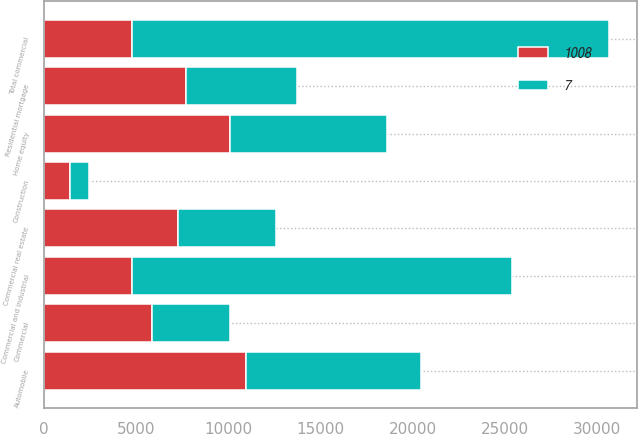Convert chart. <chart><loc_0><loc_0><loc_500><loc_500><stacked_bar_chart><ecel><fcel>Commercial and industrial<fcel>Construction<fcel>Commercial<fcel>Commercial real estate<fcel>Total commercial<fcel>Automobile<fcel>Home equity<fcel>Residential mortgage<nl><fcel>1008<fcel>4752.5<fcel>1446<fcel>5855<fcel>7301<fcel>4752.5<fcel>10969<fcel>10106<fcel>7725<nl><fcel>nan<fcel>42<fcel>2<fcel>9<fcel>11<fcel>53<fcel>16<fcel>15<fcel>12<nl><fcel>7<fcel>20560<fcel>1031<fcel>4237<fcel>5268<fcel>25828<fcel>9481<fcel>8471<fcel>5998<nl></chart> 